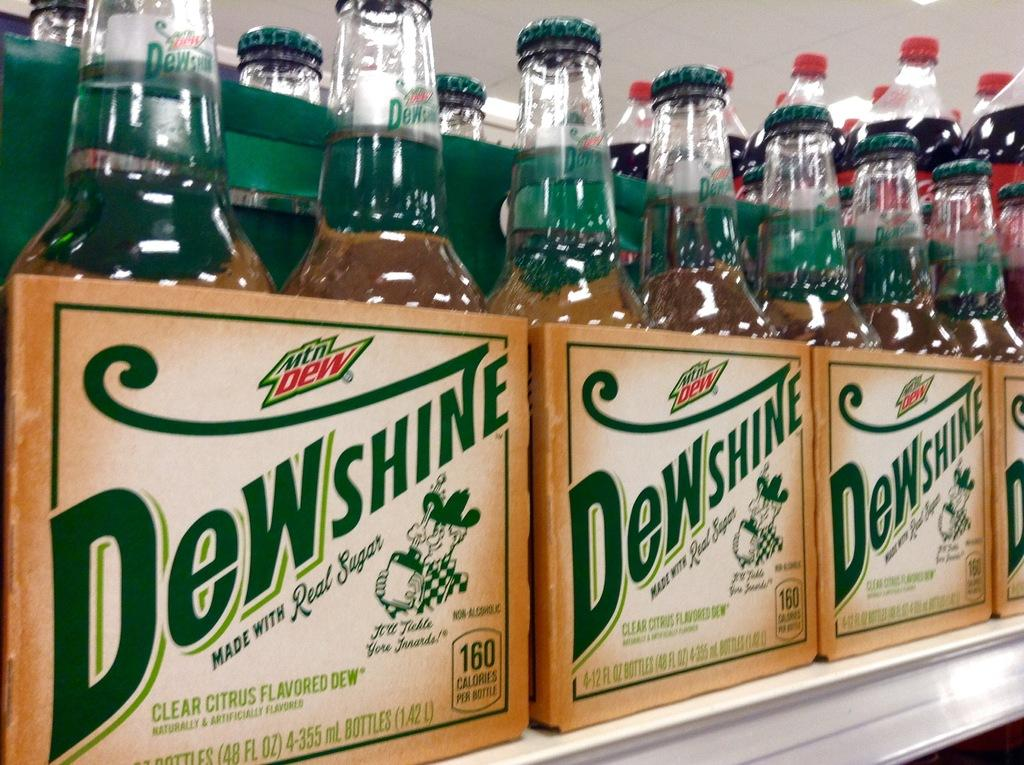Provide a one-sentence caption for the provided image. Several sixpacks of Dewshine in glass bottles on a shelf. 